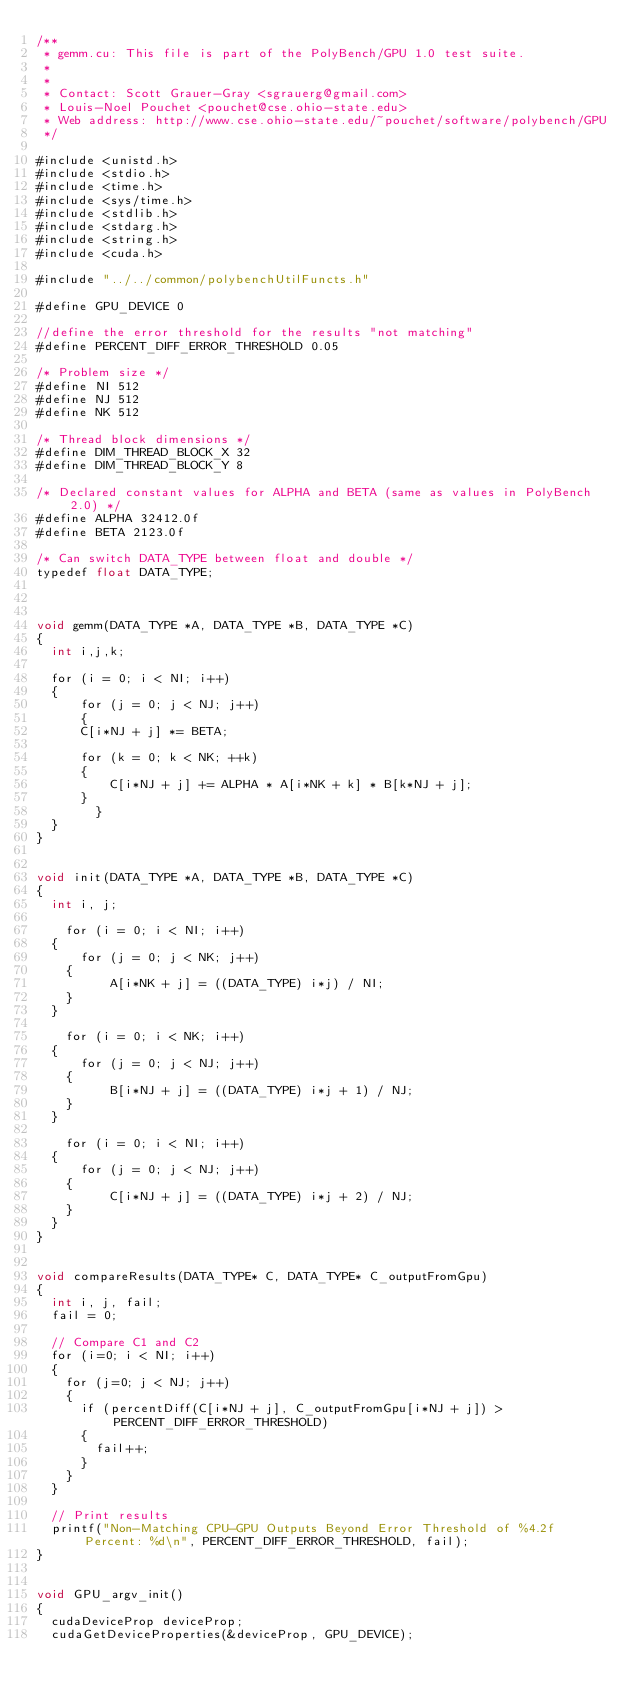Convert code to text. <code><loc_0><loc_0><loc_500><loc_500><_Cuda_>/**
 * gemm.cu: This file is part of the PolyBench/GPU 1.0 test suite.
 *
 *
 * Contact: Scott Grauer-Gray <sgrauerg@gmail.com>
 * Louis-Noel Pouchet <pouchet@cse.ohio-state.edu>
 * Web address: http://www.cse.ohio-state.edu/~pouchet/software/polybench/GPU
 */

#include <unistd.h>
#include <stdio.h>
#include <time.h>
#include <sys/time.h>
#include <stdlib.h>
#include <stdarg.h>
#include <string.h>
#include <cuda.h>

#include "../../common/polybenchUtilFuncts.h"

#define GPU_DEVICE 0

//define the error threshold for the results "not matching"
#define PERCENT_DIFF_ERROR_THRESHOLD 0.05

/* Problem size */
#define NI 512
#define NJ 512
#define NK 512

/* Thread block dimensions */
#define DIM_THREAD_BLOCK_X 32
#define DIM_THREAD_BLOCK_Y 8

/* Declared constant values for ALPHA and BETA (same as values in PolyBench 2.0) */
#define ALPHA 32412.0f
#define BETA 2123.0f

/* Can switch DATA_TYPE between float and double */
typedef float DATA_TYPE;



void gemm(DATA_TYPE *A, DATA_TYPE *B, DATA_TYPE *C)
{
	int i,j,k;
	
	for (i = 0; i < NI; i++)
	{
    	for (j = 0; j < NJ; j++)
    	{
			C[i*NJ + j] *= BETA;
	
			for (k = 0; k < NK; ++k)
			{
	  			C[i*NJ + j] += ALPHA * A[i*NK + k] * B[k*NJ + j];
			}
      	}
	}
}


void init(DATA_TYPE *A, DATA_TYPE *B, DATA_TYPE *C)
{
	int i, j;

  	for (i = 0; i < NI; i++)
	{
    	for (j = 0; j < NK; j++)
		{
      		A[i*NK + j] = ((DATA_TYPE) i*j) / NI;
		}
	}

  	for (i = 0; i < NK; i++)
	{
    	for (j = 0; j < NJ; j++)
		{
      		B[i*NJ + j] = ((DATA_TYPE) i*j + 1) / NJ;
		}
	}

  	for (i = 0; i < NI; i++)
	{
    	for (j = 0; j < NJ; j++)
		{
      		C[i*NJ + j] = ((DATA_TYPE) i*j + 2) / NJ;
		}
	}
}


void compareResults(DATA_TYPE* C, DATA_TYPE* C_outputFromGpu)
{
	int i, j, fail;
	fail = 0;
	
	// Compare C1 and C2
	for (i=0; i < NI; i++) 
	{
		for (j=0; j < NJ; j++) 
		{
			if (percentDiff(C[i*NJ + j], C_outputFromGpu[i*NJ + j]) > PERCENT_DIFF_ERROR_THRESHOLD) 
			{
				fail++;
			}
		}
	}
	
	// Print results
	printf("Non-Matching CPU-GPU Outputs Beyond Error Threshold of %4.2f Percent: %d\n", PERCENT_DIFF_ERROR_THRESHOLD, fail);
}


void GPU_argv_init()
{
	cudaDeviceProp deviceProp;
	cudaGetDeviceProperties(&deviceProp, GPU_DEVICE);</code> 